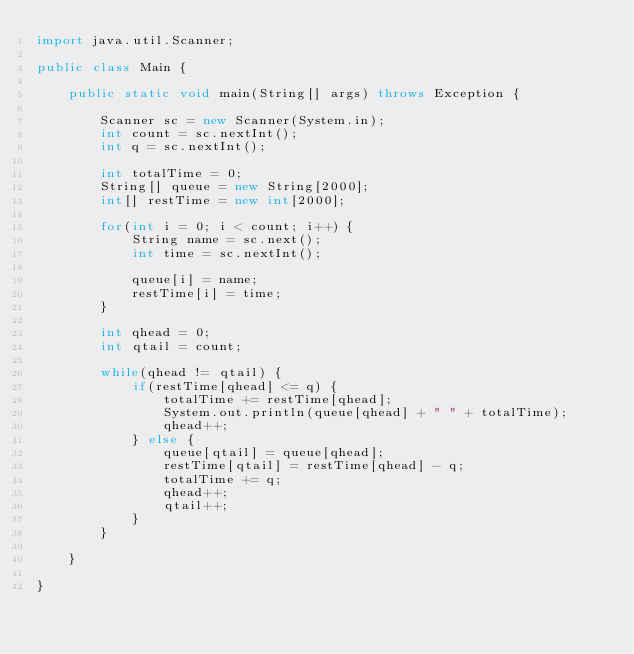<code> <loc_0><loc_0><loc_500><loc_500><_Java_>import java.util.Scanner;

public class Main {

	public static void main(String[] args) throws Exception {

		Scanner sc = new Scanner(System.in);
		int count = sc.nextInt();
		int q = sc.nextInt();

		int totalTime = 0;
		String[] queue = new String[2000];
		int[] restTime = new int[2000];

		for(int i = 0; i < count; i++) {
			String name = sc.next();
			int time = sc.nextInt();

			queue[i] = name;
			restTime[i] = time;
		}

		int qhead = 0;
		int qtail = count;

		while(qhead != qtail) {
			if(restTime[qhead] <= q) {
				totalTime += restTime[qhead];
				System.out.println(queue[qhead] + " " + totalTime);
				qhead++;
			} else {
				queue[qtail] = queue[qhead];
				restTime[qtail] = restTime[qhead] - q;
				totalTime += q;
				qhead++;
				qtail++;
			}
		}

	}

}
</code> 